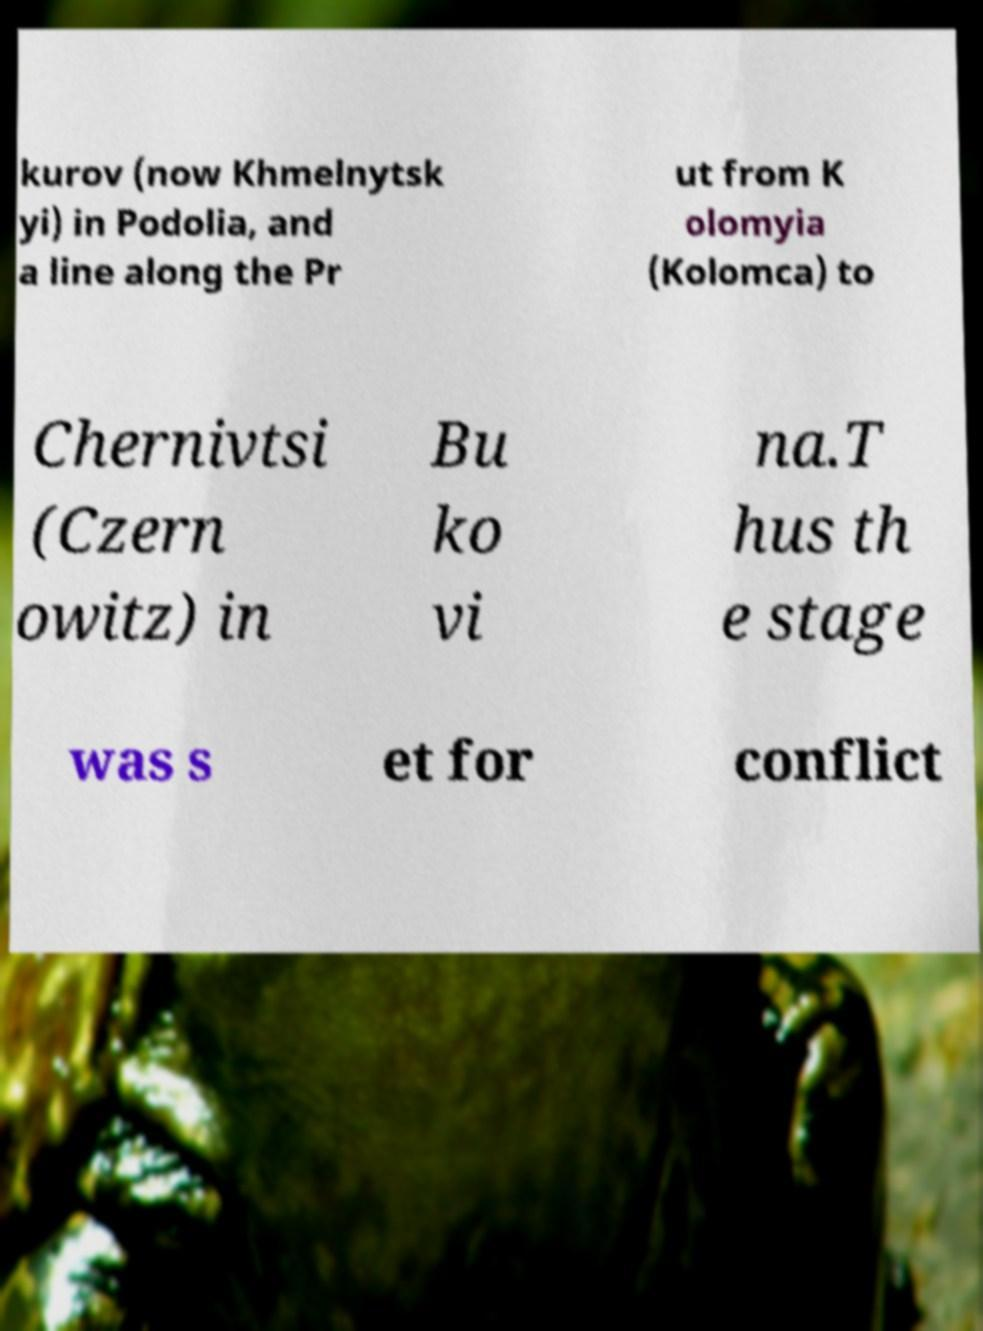I need the written content from this picture converted into text. Can you do that? kurov (now Khmelnytsk yi) in Podolia, and a line along the Pr ut from K olomyia (Kolomca) to Chernivtsi (Czern owitz) in Bu ko vi na.T hus th e stage was s et for conflict 